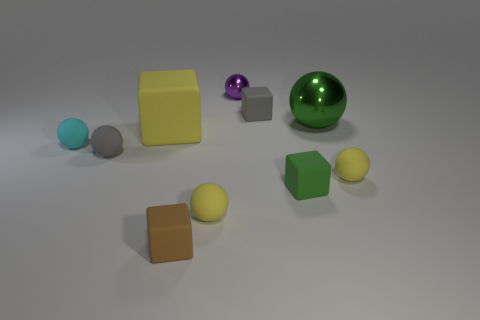There is a big yellow object that is the same material as the small gray cube; what is its shape?
Keep it short and to the point. Cube. Are there any purple rubber cylinders?
Your response must be concise. No. Is the number of big metallic balls in front of the small gray ball less than the number of purple shiny things that are on the left side of the large cube?
Offer a terse response. No. What shape is the small yellow thing right of the purple sphere?
Give a very brief answer. Sphere. Is the small cyan ball made of the same material as the small purple object?
Provide a short and direct response. No. What material is the small cyan thing that is the same shape as the small purple shiny thing?
Your answer should be compact. Rubber. Is the number of tiny matte things that are behind the large yellow object less than the number of small rubber things?
Keep it short and to the point. Yes. What number of gray spheres are to the left of the large matte block?
Your answer should be compact. 1. There is a yellow rubber object that is on the right side of the tiny green cube; is it the same shape as the gray matte object that is behind the cyan matte sphere?
Give a very brief answer. No. There is a thing that is behind the yellow cube and right of the green rubber thing; what shape is it?
Provide a succinct answer. Sphere. 